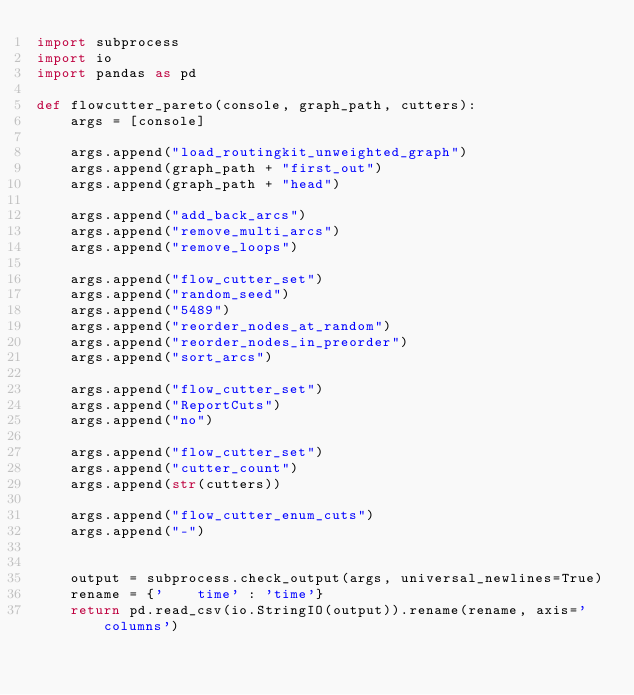Convert code to text. <code><loc_0><loc_0><loc_500><loc_500><_Python_>import subprocess
import io
import pandas as pd

def flowcutter_pareto(console, graph_path, cutters):
    args = [console]

    args.append("load_routingkit_unweighted_graph")
    args.append(graph_path + "first_out")
    args.append(graph_path + "head")

    args.append("add_back_arcs")
    args.append("remove_multi_arcs")
    args.append("remove_loops")

    args.append("flow_cutter_set")
    args.append("random_seed")
    args.append("5489")
    args.append("reorder_nodes_at_random")
    args.append("reorder_nodes_in_preorder")
    args.append("sort_arcs")

    args.append("flow_cutter_set")
    args.append("ReportCuts")
    args.append("no")

    args.append("flow_cutter_set")
    args.append("cutter_count")
    args.append(str(cutters))

    args.append("flow_cutter_enum_cuts")
    args.append("-")


    output = subprocess.check_output(args, universal_newlines=True)
    rename = {'    time' : 'time'}
    return pd.read_csv(io.StringIO(output)).rename(rename, axis='columns')


</code> 